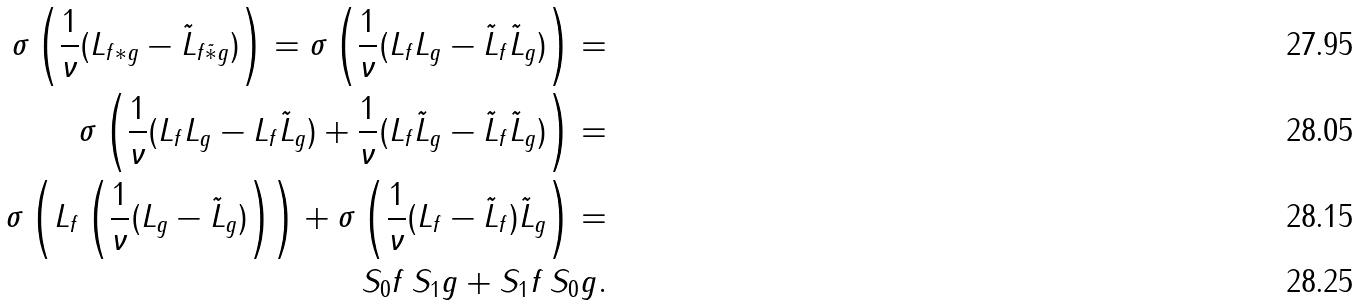<formula> <loc_0><loc_0><loc_500><loc_500>\sigma \left ( \frac { 1 } { \nu } ( L _ { f \ast g } - \tilde { L } _ { f \tilde { \ast } g } ) \right ) = \sigma \left ( \frac { 1 } { \nu } ( L _ { f } L _ { g } - \tilde { L } _ { f } \tilde { L } _ { g } ) \right ) = \\ \sigma \left ( \frac { 1 } { \nu } ( L _ { f } L _ { g } - L _ { f } \tilde { L } _ { g } ) + \frac { 1 } { \nu } ( L _ { f } \tilde { L } _ { g } - \tilde { L } _ { f } \tilde { L } _ { g } ) \right ) = \\ \sigma \left ( L _ { f } \left ( \frac { 1 } { \nu } ( L _ { g } - \tilde { L } _ { g } ) \right ) \right ) + \sigma \left ( \frac { 1 } { \nu } ( L _ { f } - \tilde { L } _ { f } ) \tilde { L } _ { g } \right ) = \\ S _ { 0 } f \, S _ { 1 } g + S _ { 1 } f \, S _ { 0 } g .</formula> 